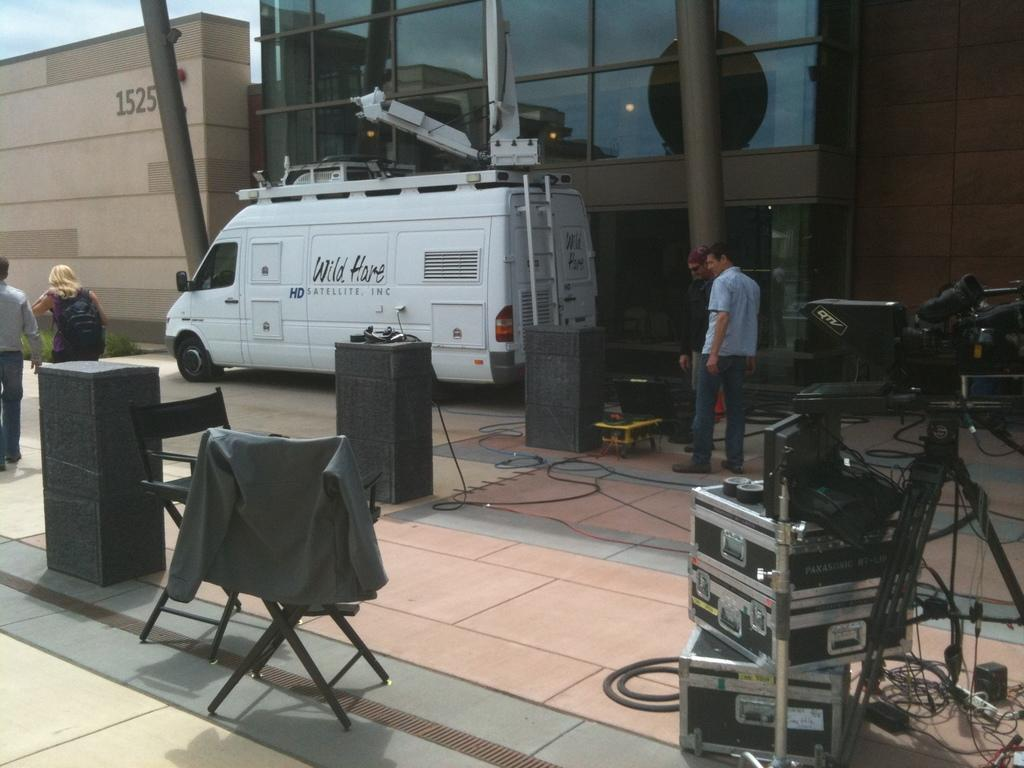What are the people in the image doing? There are persons standing on the road in the image. What else can be seen in the image besides the people? There is a vehicle and electronic devices in the image. What is visible in the background of the image? There is a building and the sky in the background of the image. What type of leaf is being used for reading in the image? There is no leaf present in the image, nor is anyone reading in the image. 